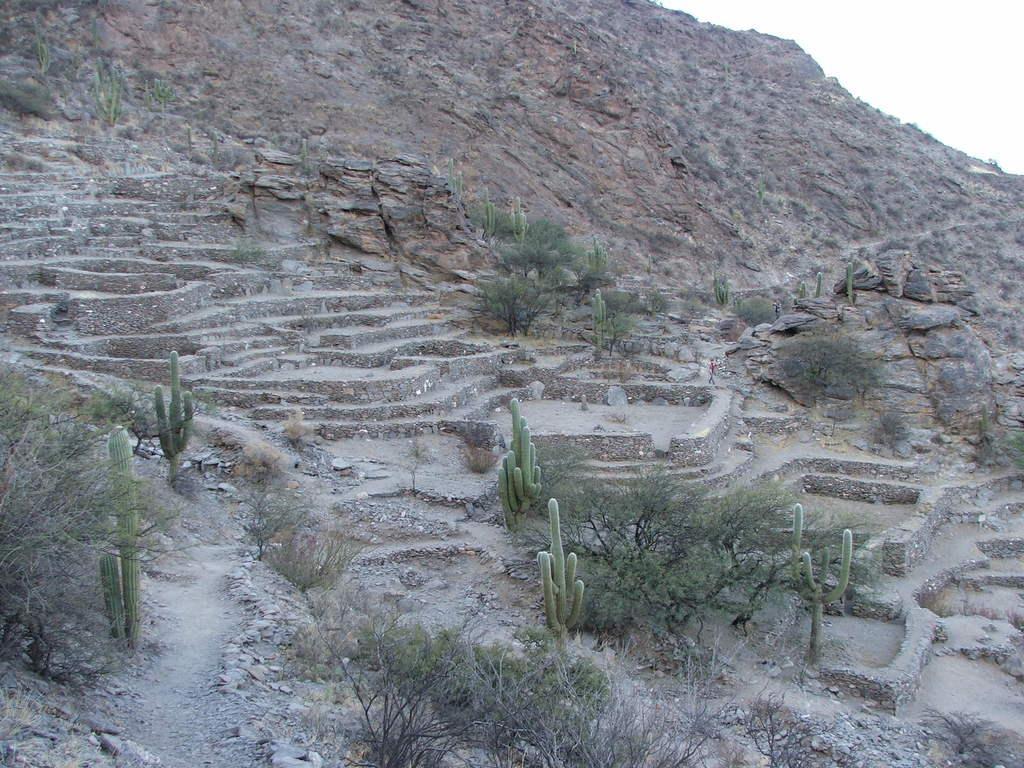Describe this image in one or two sentences. In this image there is a person on the stairs, few plants, a mountain and the sky. 